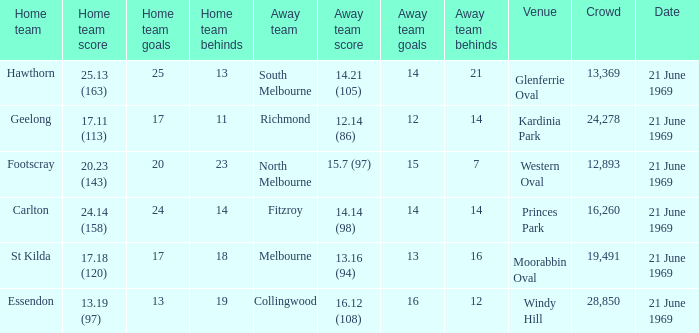What is Essendon's home team that has an away crowd size larger than 19,491? Collingwood. 